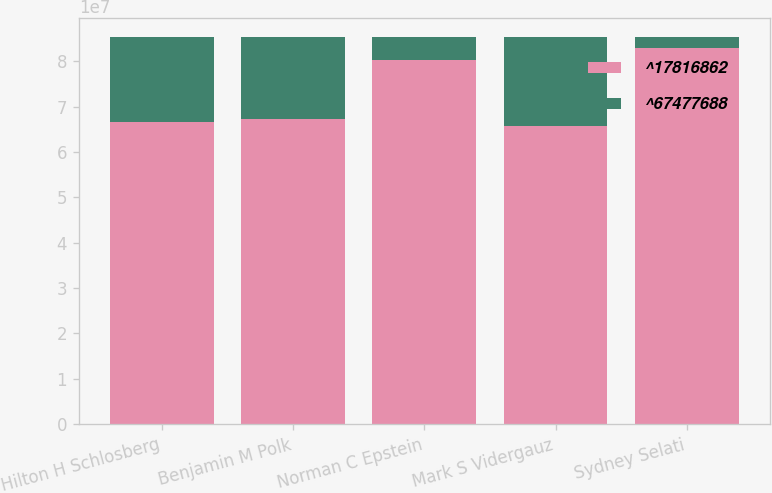Convert chart to OTSL. <chart><loc_0><loc_0><loc_500><loc_500><stacked_bar_chart><ecel><fcel>Hilton H Schlosberg<fcel>Benjamin M Polk<fcel>Norman C Epstein<fcel>Mark S Vidergauz<fcel>Sydney Selati<nl><fcel>^17816862<fcel>6.65704e+07<fcel>6.7241e+07<fcel>8.02102e+07<fcel>6.57203e+07<fcel>8.28813e+07<nl><fcel>^67477688<fcel>1.87241e+07<fcel>1.80536e+07<fcel>5.08437e+06<fcel>1.95742e+07<fcel>2.41326e+06<nl></chart> 